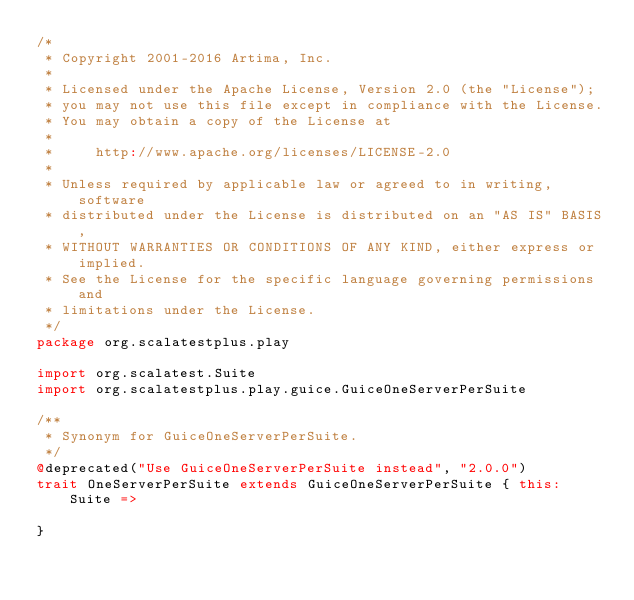<code> <loc_0><loc_0><loc_500><loc_500><_Scala_>/*
 * Copyright 2001-2016 Artima, Inc.
 *
 * Licensed under the Apache License, Version 2.0 (the "License");
 * you may not use this file except in compliance with the License.
 * You may obtain a copy of the License at
 *
 *     http://www.apache.org/licenses/LICENSE-2.0
 *
 * Unless required by applicable law or agreed to in writing, software
 * distributed under the License is distributed on an "AS IS" BASIS,
 * WITHOUT WARRANTIES OR CONDITIONS OF ANY KIND, either express or implied.
 * See the License for the specific language governing permissions and
 * limitations under the License.
 */
package org.scalatestplus.play

import org.scalatest.Suite
import org.scalatestplus.play.guice.GuiceOneServerPerSuite

/**
 * Synonym for GuiceOneServerPerSuite.
 */
@deprecated("Use GuiceOneServerPerSuite instead", "2.0.0")
trait OneServerPerSuite extends GuiceOneServerPerSuite { this: Suite =>

}
</code> 